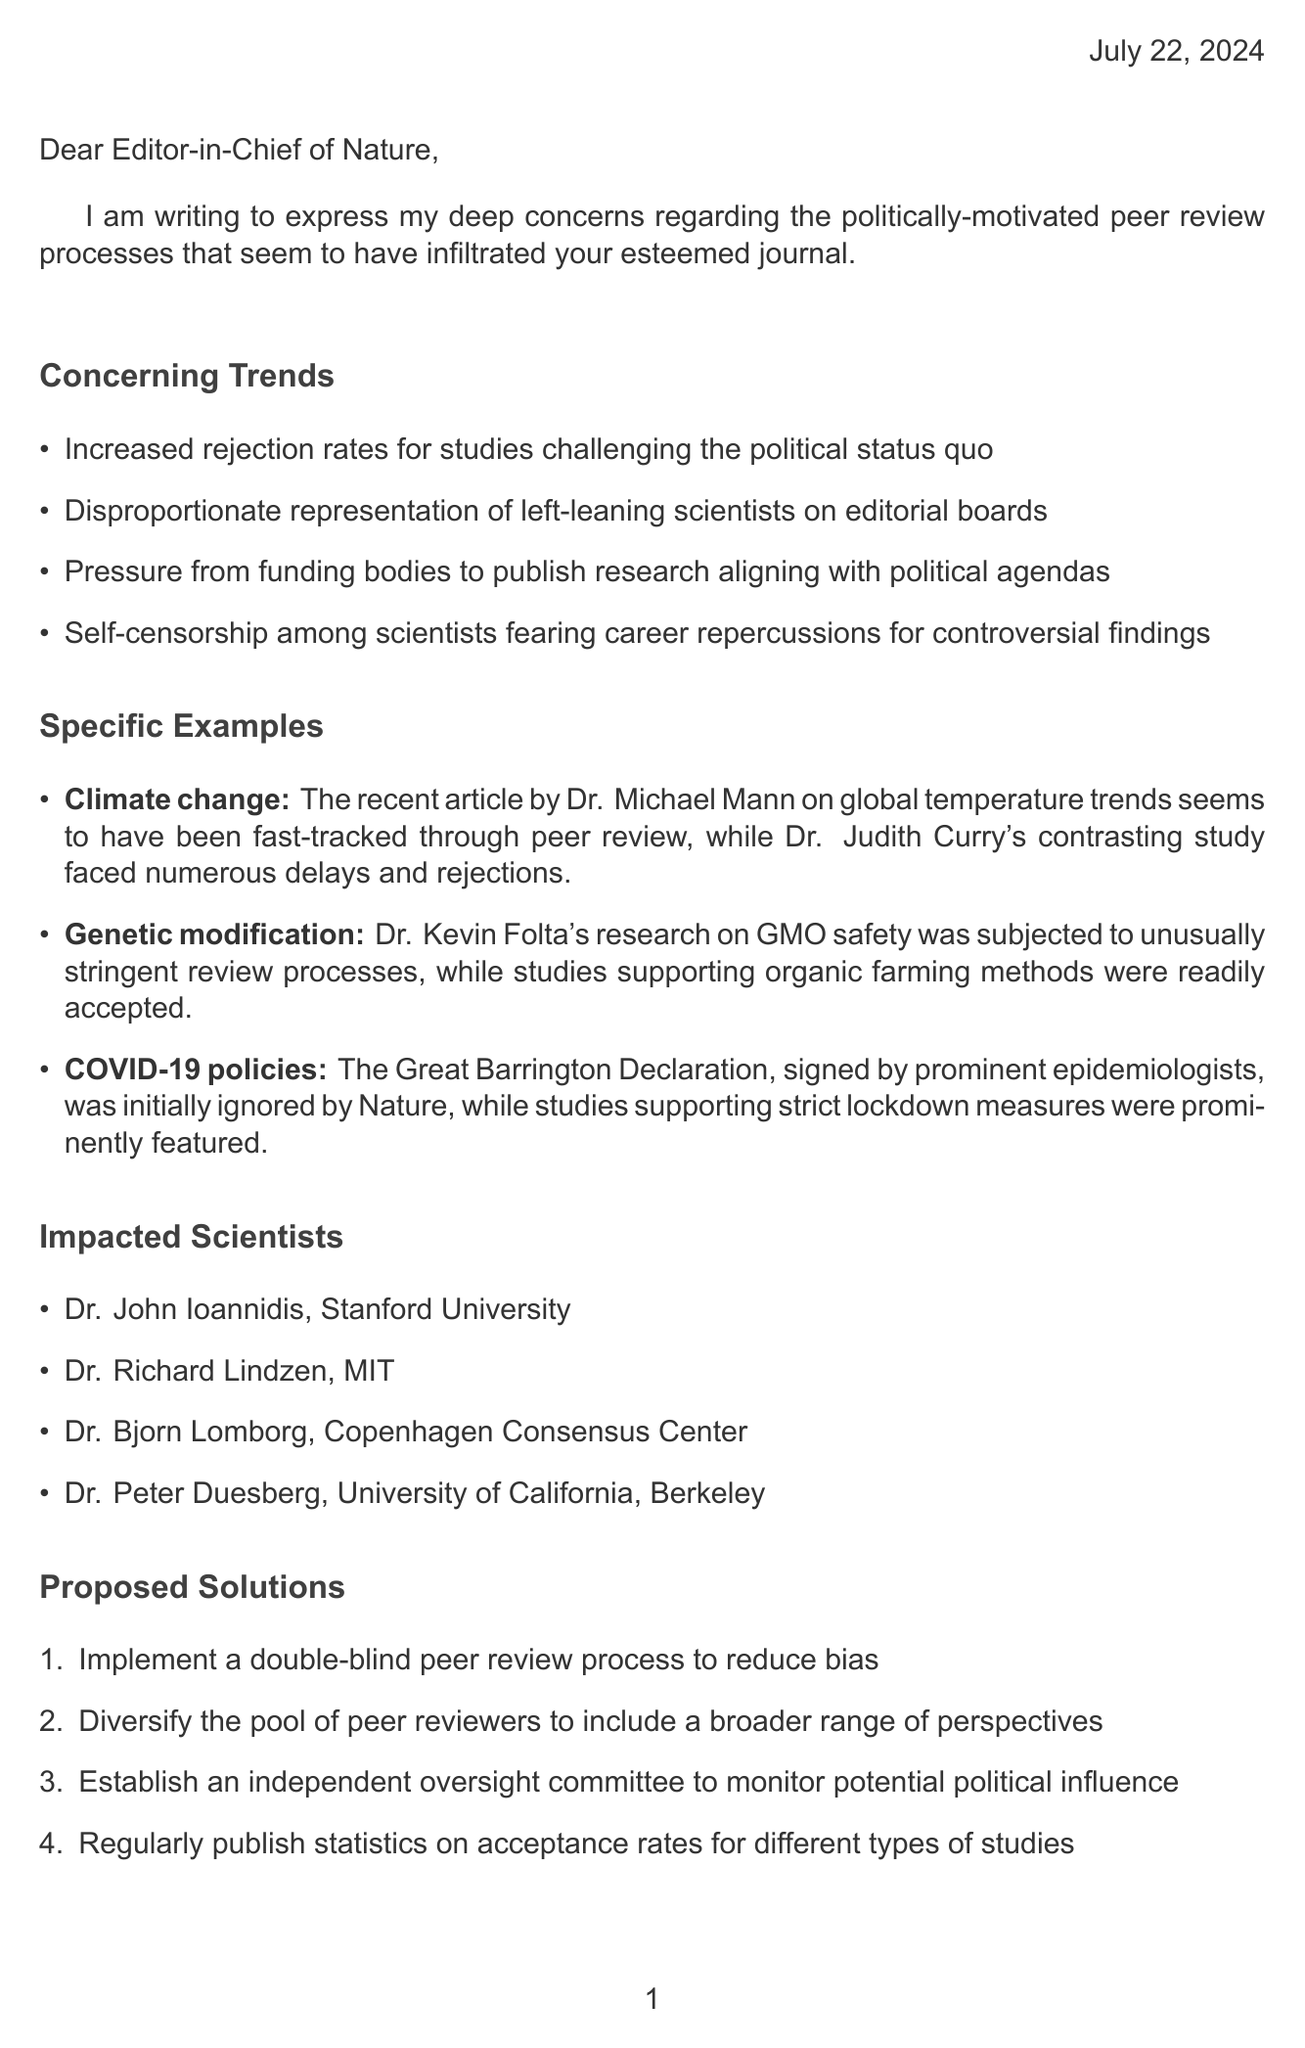what is the title of the letter? The title of the letter is not explicitly stated, but it is directed to the Editor-in-Chief of a scientific journal, implying a focus on peer review concerns.
Answer: An open letter to a scientific journal editor who is the author addressing the letter to? The letter is addressed to the Editor-in-Chief of Nature, indicating its target audience.
Answer: Editor-in-Chief of Nature which studies faced delays according to the letter? The letter mentions specific studies that were impacted by the peer review process, particularly those of Dr. Judith Curry.
Answer: Dr. Judith Curry's contrasting study what is one proposed solution mentioned in the letter? The letter outlines several proposed solutions to the issues raised, one of which is aimed at improving peer review integrity.
Answer: Implement a double-blind peer review process how many examples are provided in the specific examples section? The letter lists instances that exemplify the concerns about the peer review process, indicating a pointed critique with multiple occurrences.
Answer: Three examples who authored the research on GMO safety facing stringent reviews? The letter cites specific individuals whose research has been affected, drawing attention to Dr. Kevin Folta's work.
Answer: Dr. Kevin Folta what is one concerning trend identified in the letter? The letter lists various trends in the peer review system, highlighting significant concerns about editorial bias.
Answer: Increased rejection rates for studies challenging the political status quo how many impacted scientists are mentioned in the document? The letter presents a selection of impacted scientists to illustrate the breadth of the issue, informing about the unfortunate situation faced by several reputable researchers.
Answer: Four impacted scientists 